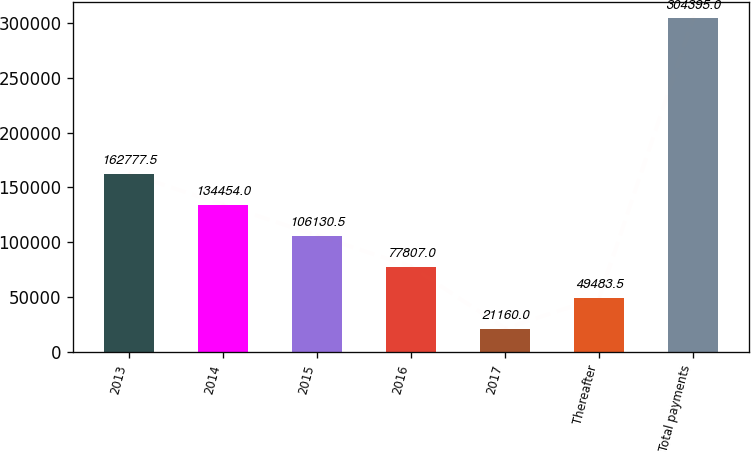<chart> <loc_0><loc_0><loc_500><loc_500><bar_chart><fcel>2013<fcel>2014<fcel>2015<fcel>2016<fcel>2017<fcel>Thereafter<fcel>Total payments<nl><fcel>162778<fcel>134454<fcel>106130<fcel>77807<fcel>21160<fcel>49483.5<fcel>304395<nl></chart> 